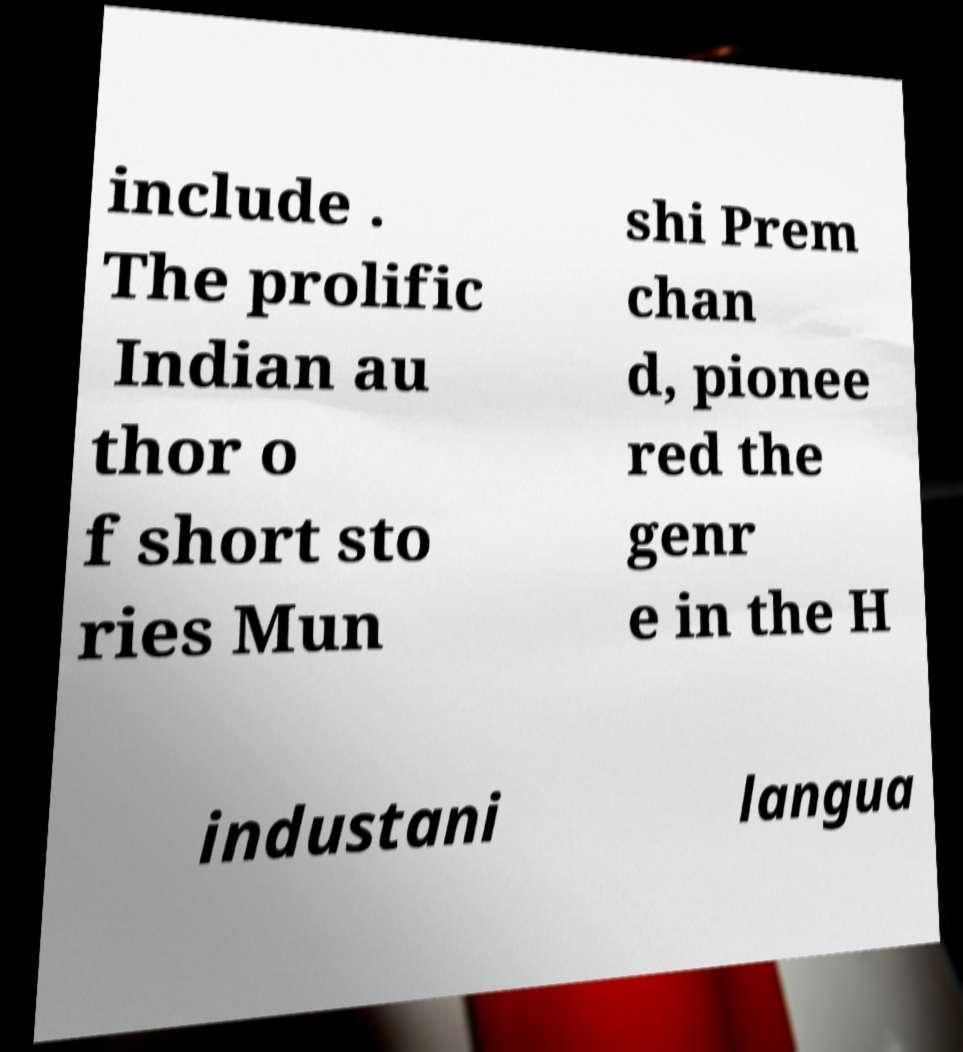There's text embedded in this image that I need extracted. Can you transcribe it verbatim? include . The prolific Indian au thor o f short sto ries Mun shi Prem chan d, pionee red the genr e in the H industani langua 